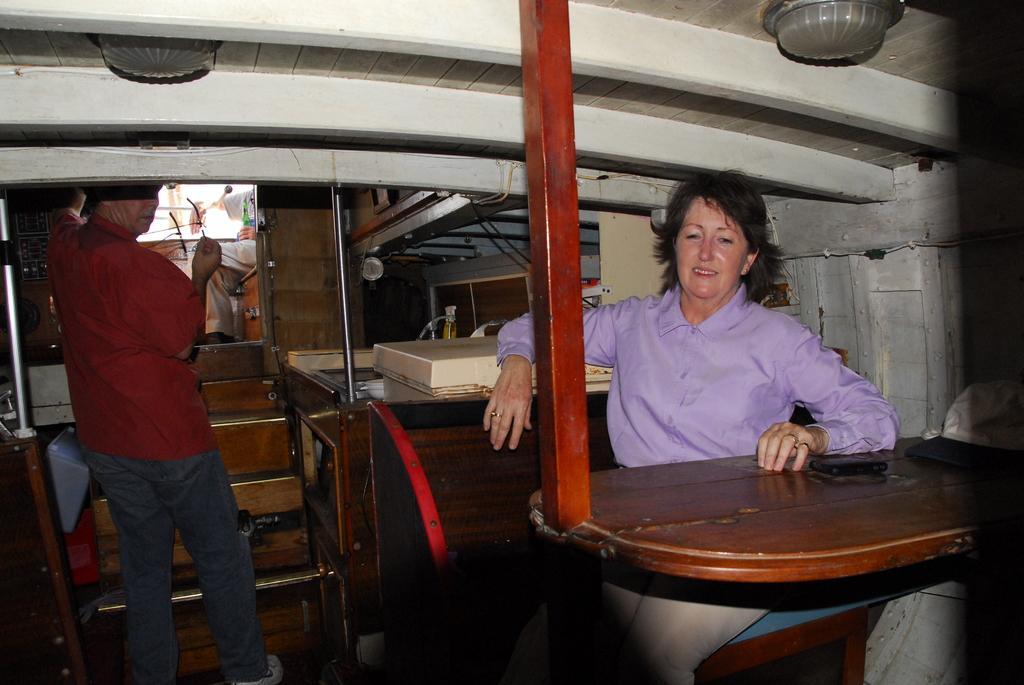How would you summarize this image in a sentence or two? In this image we can see a man is standing on the left side and on the right side there is a woman is sitting on the chair at the table and on the table we can see a mobile and a cap and we can see poles, steps, bottle and lights on the top. In the background we can see a person is sitting on a platform and holding a bottle in the hand. 